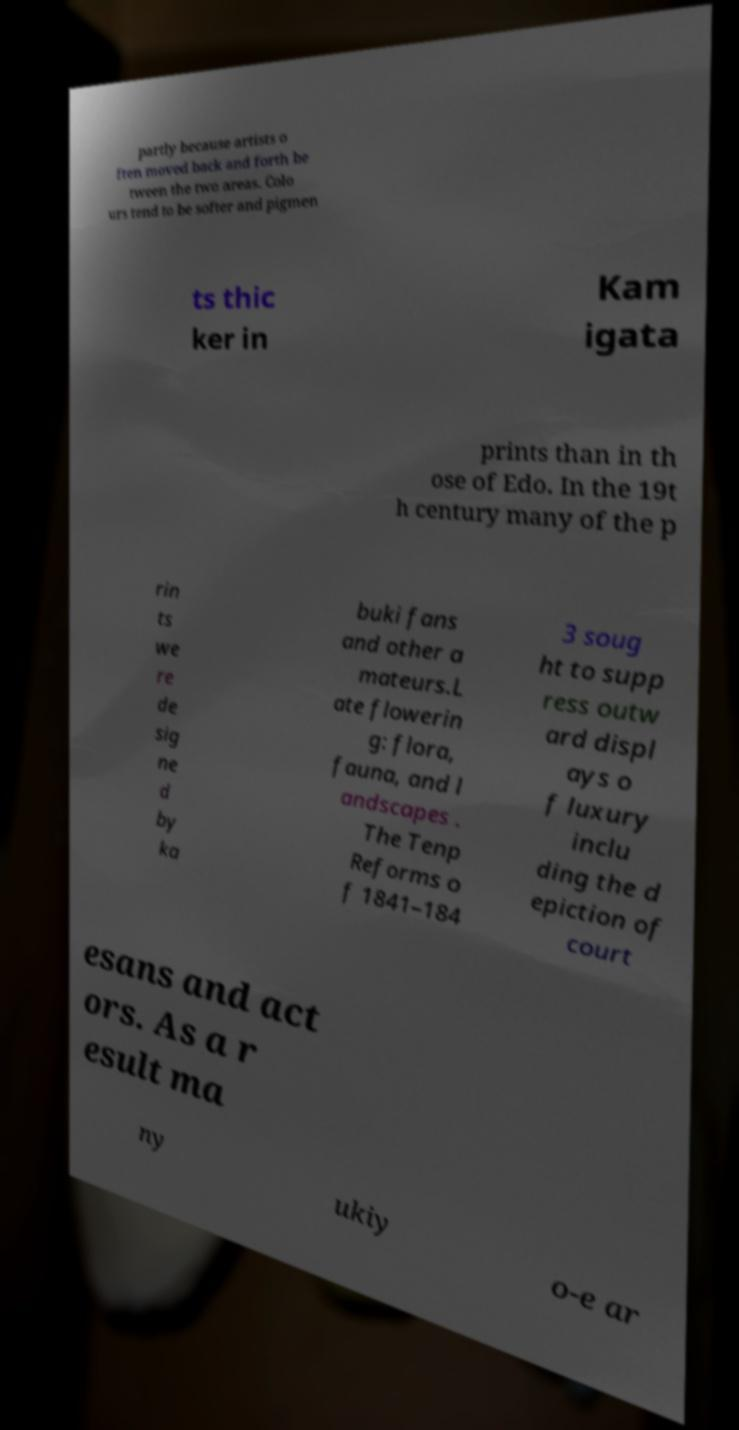For documentation purposes, I need the text within this image transcribed. Could you provide that? partly because artists o ften moved back and forth be tween the two areas. Colo urs tend to be softer and pigmen ts thic ker in Kam igata prints than in th ose of Edo. In the 19t h century many of the p rin ts we re de sig ne d by ka buki fans and other a mateurs.L ate flowerin g: flora, fauna, and l andscapes . The Tenp Reforms o f 1841–184 3 soug ht to supp ress outw ard displ ays o f luxury inclu ding the d epiction of court esans and act ors. As a r esult ma ny ukiy o-e ar 